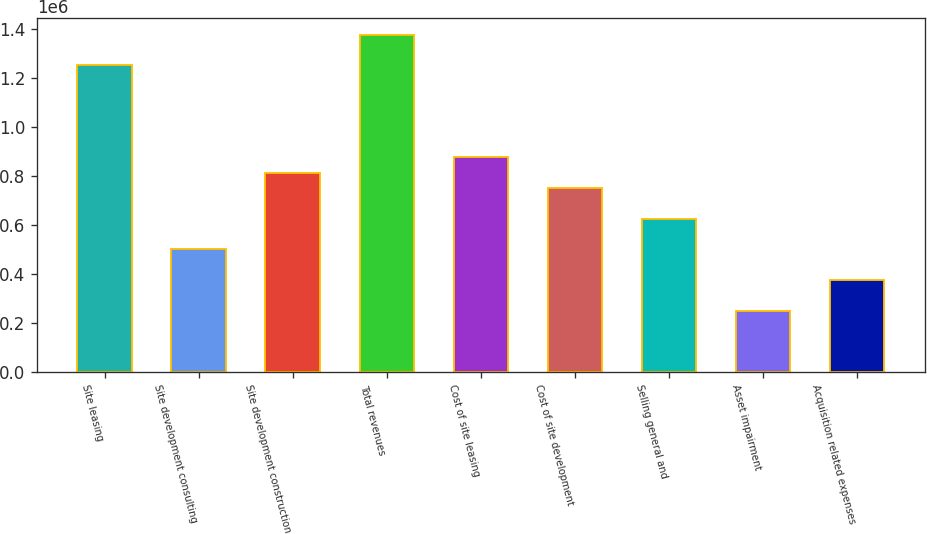<chart> <loc_0><loc_0><loc_500><loc_500><bar_chart><fcel>Site leasing<fcel>Site development consulting<fcel>Site development construction<fcel>Total revenues<fcel>Cost of site leasing<fcel>Cost of site development<fcel>Selling general and<fcel>Asset impairment<fcel>Acquisition related expenses<nl><fcel>1.25321e+06<fcel>501301<fcel>814596<fcel>1.37853e+06<fcel>877255<fcel>751937<fcel>626619<fcel>250665<fcel>375983<nl></chart> 